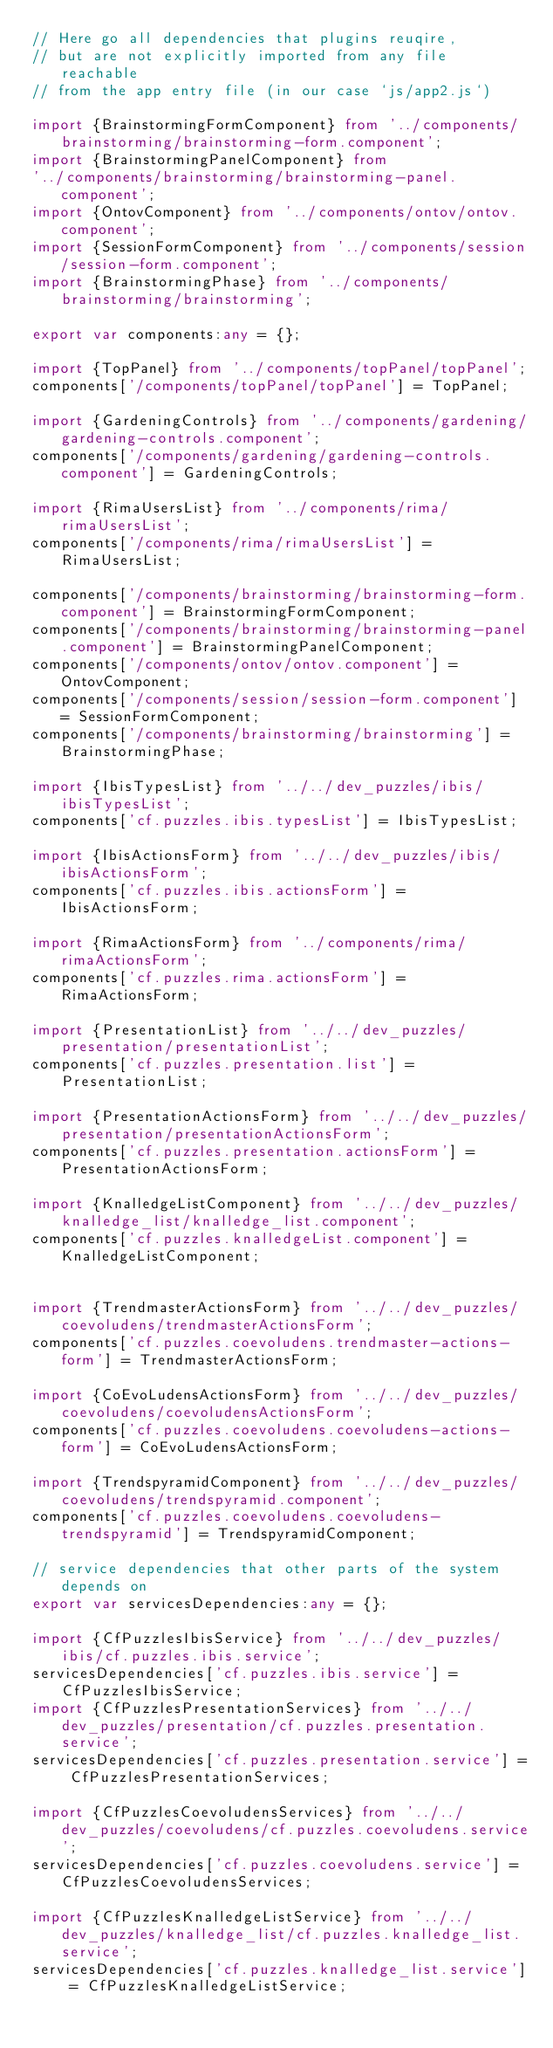Convert code to text. <code><loc_0><loc_0><loc_500><loc_500><_TypeScript_>// Here go all dependencies that plugins reuqire,
// but are not explicitly imported from any file reachable
// from the app entry file (in our case `js/app2.js`)

import {BrainstormingFormComponent} from '../components/brainstorming/brainstorming-form.component';
import {BrainstormingPanelComponent} from
'../components/brainstorming/brainstorming-panel.component';
import {OntovComponent} from '../components/ontov/ontov.component';
import {SessionFormComponent} from '../components/session/session-form.component';
import {BrainstormingPhase} from '../components/brainstorming/brainstorming';

export var components:any = {};

import {TopPanel} from '../components/topPanel/topPanel';
components['/components/topPanel/topPanel'] = TopPanel;

import {GardeningControls} from '../components/gardening/gardening-controls.component';
components['/components/gardening/gardening-controls.component'] = GardeningControls;

import {RimaUsersList} from '../components/rima/rimaUsersList';
components['/components/rima/rimaUsersList'] = RimaUsersList;

components['/components/brainstorming/brainstorming-form.component'] = BrainstormingFormComponent;
components['/components/brainstorming/brainstorming-panel.component'] = BrainstormingPanelComponent;
components['/components/ontov/ontov.component'] = OntovComponent;
components['/components/session/session-form.component'] = SessionFormComponent;
components['/components/brainstorming/brainstorming'] = BrainstormingPhase;

import {IbisTypesList} from '../../dev_puzzles/ibis/ibisTypesList';
components['cf.puzzles.ibis.typesList'] = IbisTypesList;

import {IbisActionsForm} from '../../dev_puzzles/ibis/ibisActionsForm';
components['cf.puzzles.ibis.actionsForm'] = IbisActionsForm;

import {RimaActionsForm} from '../components/rima/rimaActionsForm';
components['cf.puzzles.rima.actionsForm'] = RimaActionsForm;

import {PresentationList} from '../../dev_puzzles/presentation/presentationList';
components['cf.puzzles.presentation.list'] = PresentationList;

import {PresentationActionsForm} from '../../dev_puzzles/presentation/presentationActionsForm';
components['cf.puzzles.presentation.actionsForm'] = PresentationActionsForm;

import {KnalledgeListComponent} from '../../dev_puzzles/knalledge_list/knalledge_list.component';
components['cf.puzzles.knalledgeList.component'] = KnalledgeListComponent;


import {TrendmasterActionsForm} from '../../dev_puzzles/coevoludens/trendmasterActionsForm';
components['cf.puzzles.coevoludens.trendmaster-actions-form'] = TrendmasterActionsForm;

import {CoEvoLudensActionsForm} from '../../dev_puzzles/coevoludens/coevoludensActionsForm';
components['cf.puzzles.coevoludens.coevoludens-actions-form'] = CoEvoLudensActionsForm;

import {TrendspyramidComponent} from '../../dev_puzzles/coevoludens/trendspyramid.component';
components['cf.puzzles.coevoludens.coevoludens-trendspyramid'] = TrendspyramidComponent;

// service dependencies that other parts of the system depends on
export var servicesDependencies:any = {};

import {CfPuzzlesIbisService} from '../../dev_puzzles/ibis/cf.puzzles.ibis.service';
servicesDependencies['cf.puzzles.ibis.service'] = CfPuzzlesIbisService;
import {CfPuzzlesPresentationServices} from '../../dev_puzzles/presentation/cf.puzzles.presentation.service';
servicesDependencies['cf.puzzles.presentation.service'] = CfPuzzlesPresentationServices;

import {CfPuzzlesCoevoludensServices} from '../../dev_puzzles/coevoludens/cf.puzzles.coevoludens.service';
servicesDependencies['cf.puzzles.coevoludens.service'] = CfPuzzlesCoevoludensServices;

import {CfPuzzlesKnalledgeListService} from '../../dev_puzzles/knalledge_list/cf.puzzles.knalledge_list.service';
servicesDependencies['cf.puzzles.knalledge_list.service'] = CfPuzzlesKnalledgeListService;
</code> 